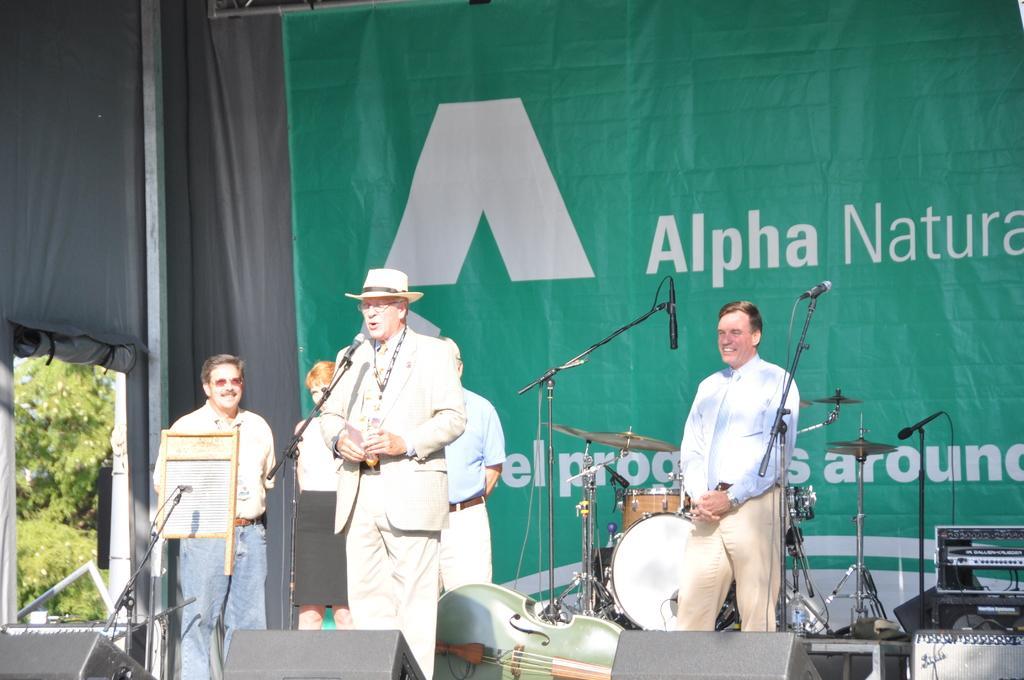Can you describe this image briefly? In this image I can see the group of people standing. I can see one person wearing the hat and standing in-front of the mic. To the side I can see the drum set and music system. In the background I can see the banner and the trees. 